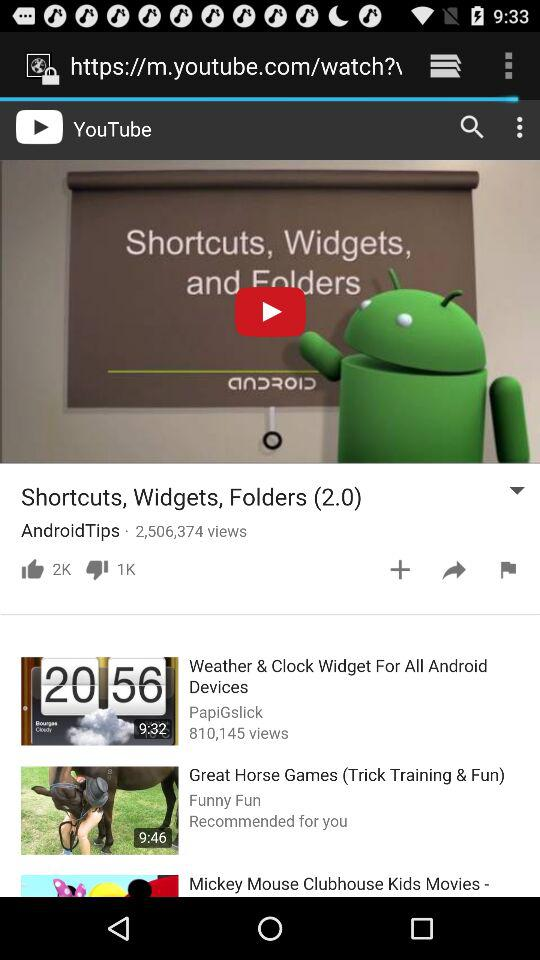How many views are on the current video? There are 2,506,374 views. 